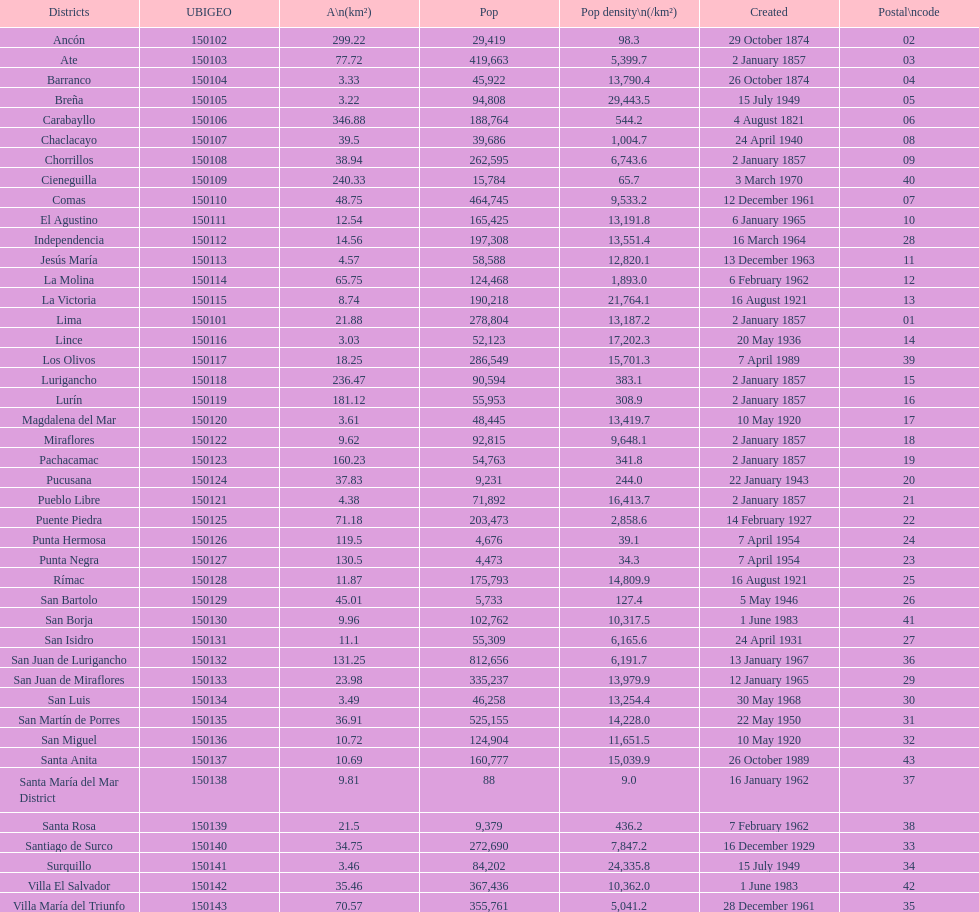Which is the largest district in terms of population? San Juan de Lurigancho. 